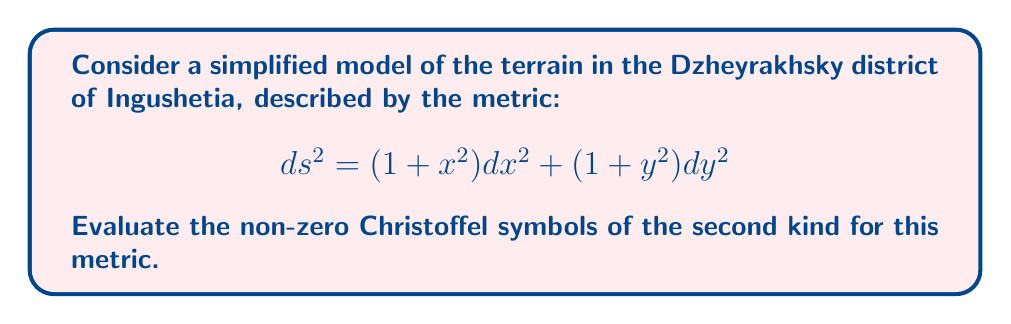Help me with this question. To evaluate the Christoffel symbols, we'll follow these steps:

1) The general formula for Christoffel symbols of the second kind is:

   $$\Gamma^k_{ij} = \frac{1}{2}g^{kl}\left(\frac{\partial g_{il}}{\partial x^j} + \frac{\partial g_{jl}}{\partial x^i} - \frac{\partial g_{ij}}{\partial x^l}\right)$$

2) First, let's identify the components of the metric tensor:
   
   $g_{11} = 1 + x^2$, $g_{22} = 1 + y^2$, $g_{12} = g_{21} = 0$

3) The inverse metric tensor is:
   
   $g^{11} = \frac{1}{1+x^2}$, $g^{22} = \frac{1}{1+y^2}$, $g^{12} = g^{21} = 0$

4) Now, let's calculate the partial derivatives:

   $\frac{\partial g_{11}}{\partial x} = 2x$, $\frac{\partial g_{22}}{\partial y} = 2y$

   All other partial derivatives are zero.

5) Let's calculate each non-zero Christoffel symbol:

   $\Gamma^1_{11} = \frac{1}{2}g^{11}\frac{\partial g_{11}}{\partial x} = \frac{1}{2}\cdot\frac{1}{1+x^2}\cdot 2x = \frac{x}{1+x^2}$

   $\Gamma^2_{22} = \frac{1}{2}g^{22}\frac{\partial g_{22}}{\partial y} = \frac{1}{2}\cdot\frac{1}{1+y^2}\cdot 2y = \frac{y}{1+y^2}$

6) All other Christoffel symbols are zero due to the diagonal nature of the metric and the fact that $g_{12} = g_{21} = 0$.
Answer: $\Gamma^1_{11} = \frac{x}{1+x^2}$, $\Gamma^2_{22} = \frac{y}{1+y^2}$, all others are zero. 